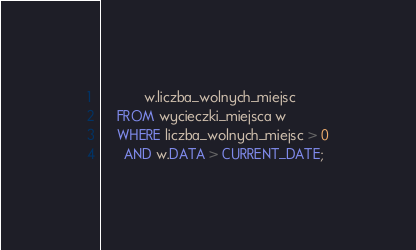<code> <loc_0><loc_0><loc_500><loc_500><_SQL_>           w.liczba_wolnych_miejsc
    FROM wycieczki_miejsca w
    WHERE liczba_wolnych_miejsc > 0
      AND w.DATA > CURRENT_DATE;
</code> 